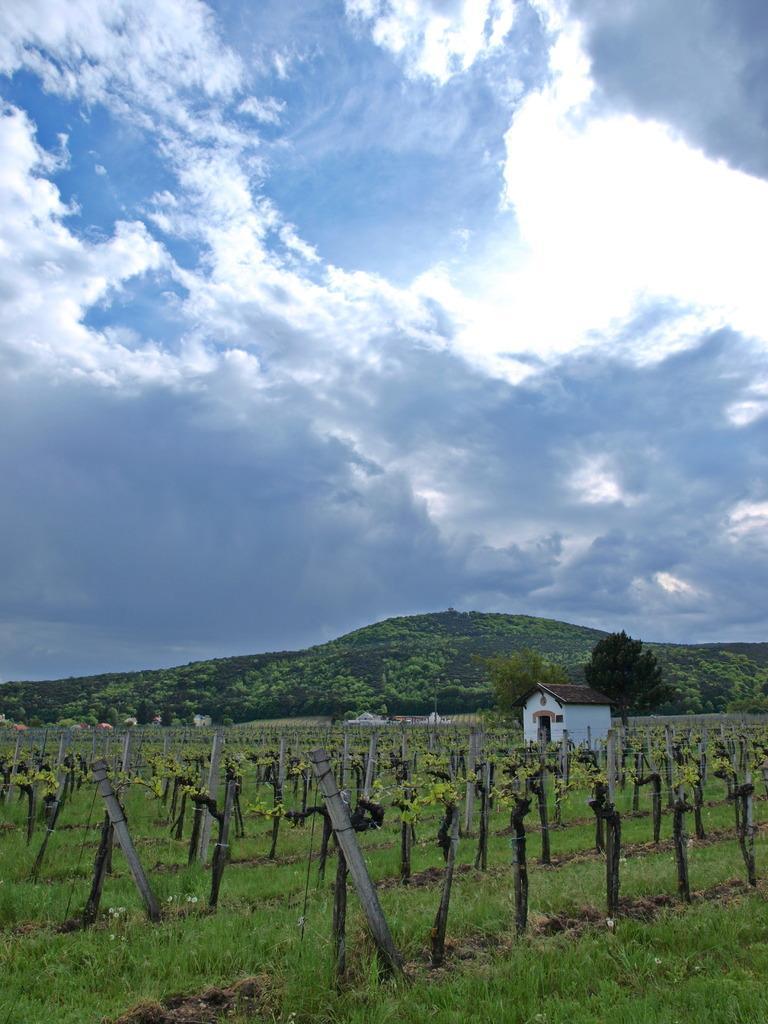Could you give a brief overview of what you see in this image? In this image we can see hill, trees, fencing, grass, house, sky and clouds. 